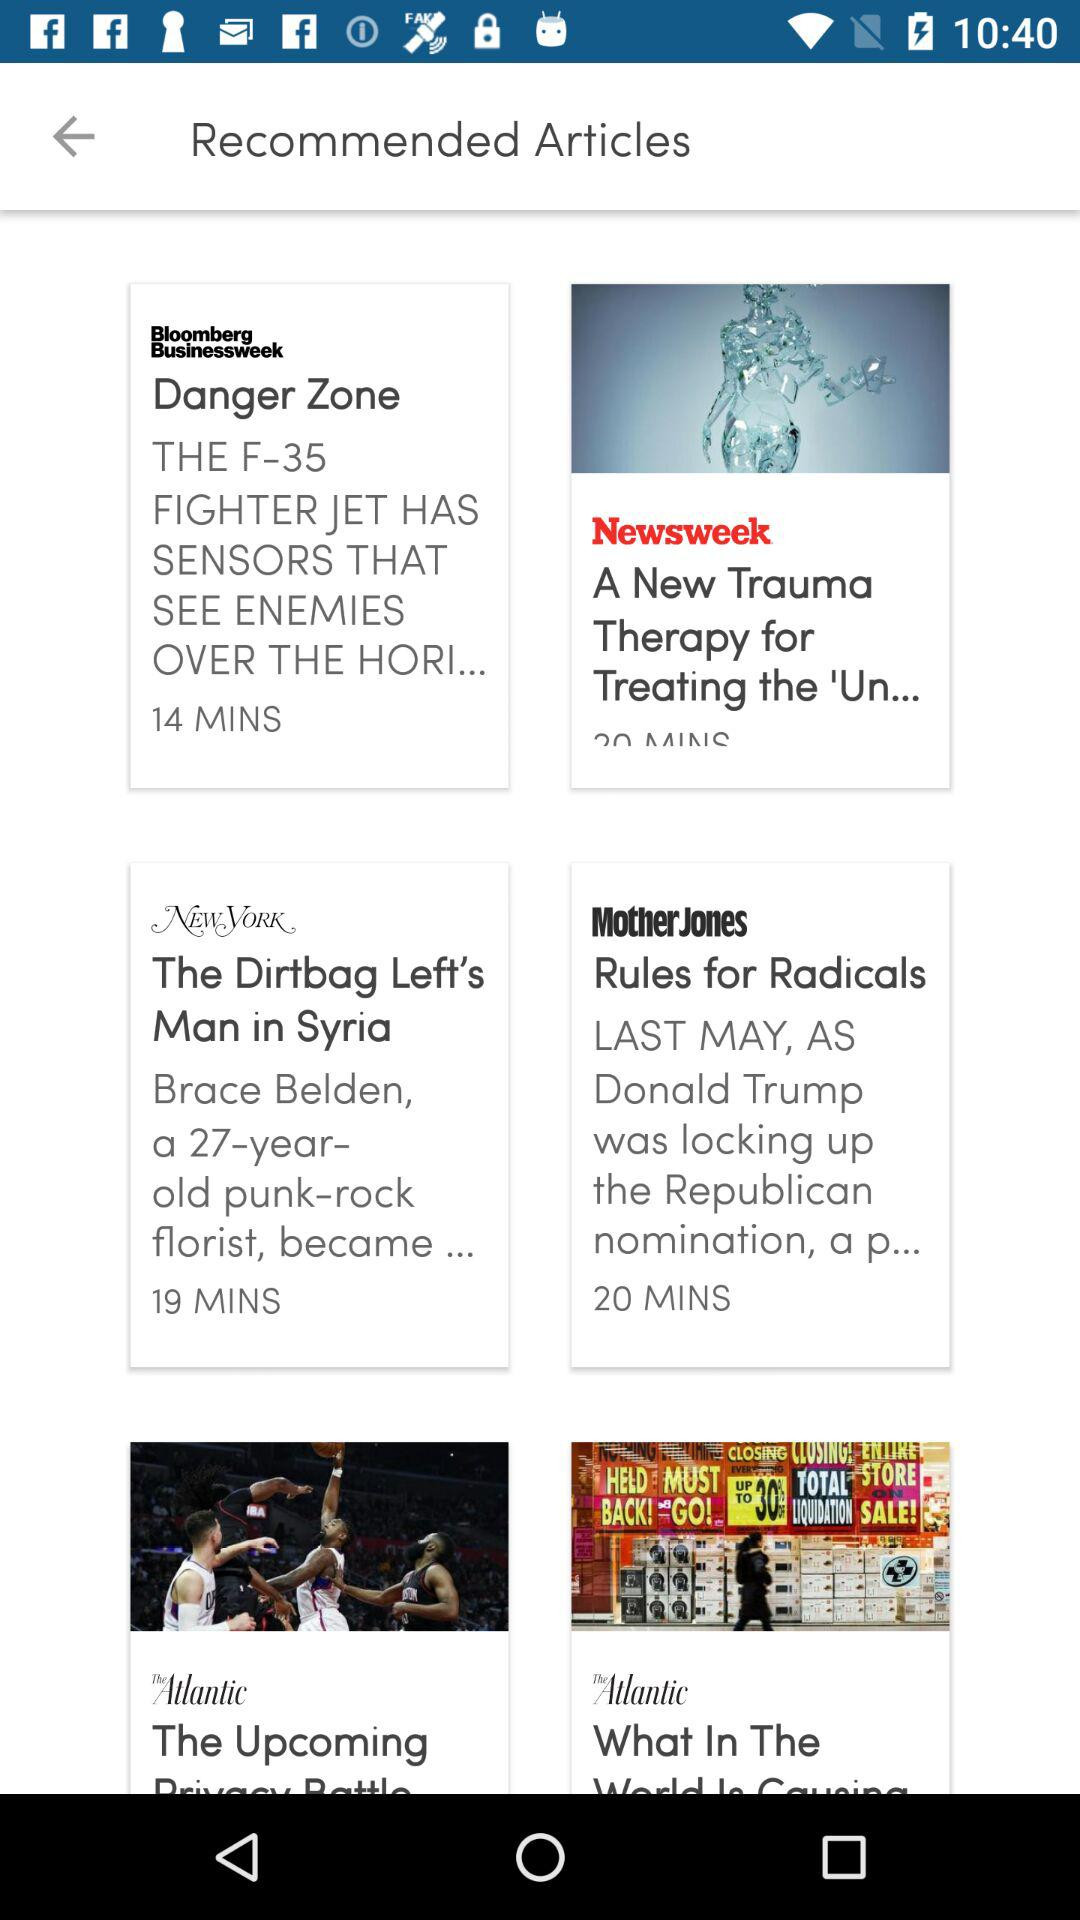In which magazine was the article "Rules for Radicals" published? The article "Rules for Radicals" was published in the magazine "Mother Jones". 